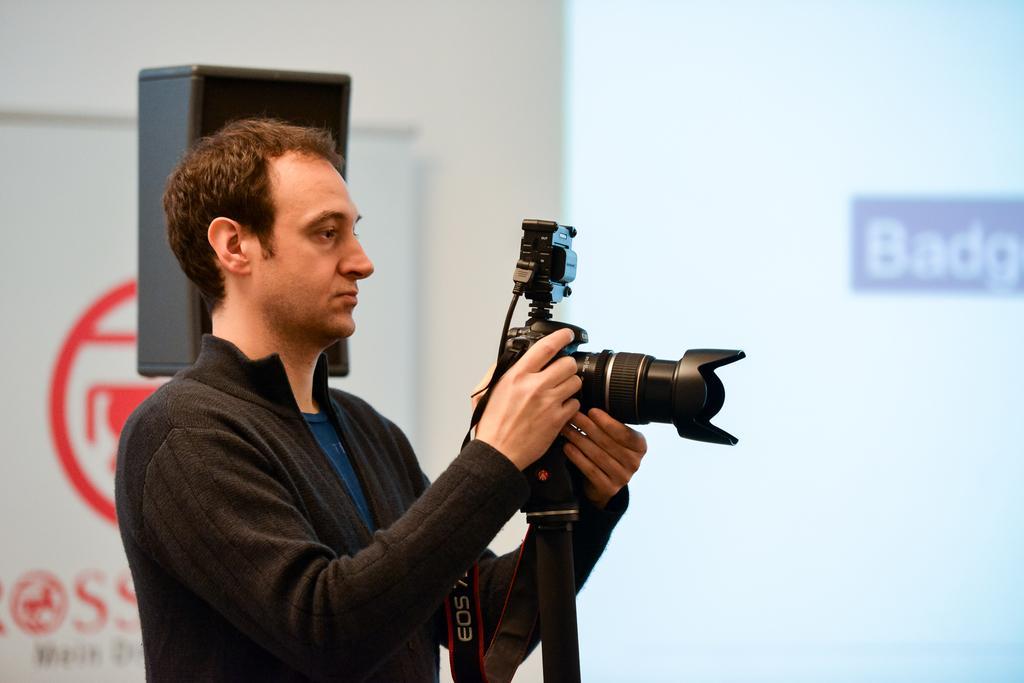Can you describe this image briefly? In this image I can see a person wearing black and blue colored dress is holding a black colored camera in his hands. In the background I can see a speaker, a screen and a white and red colored banner. 